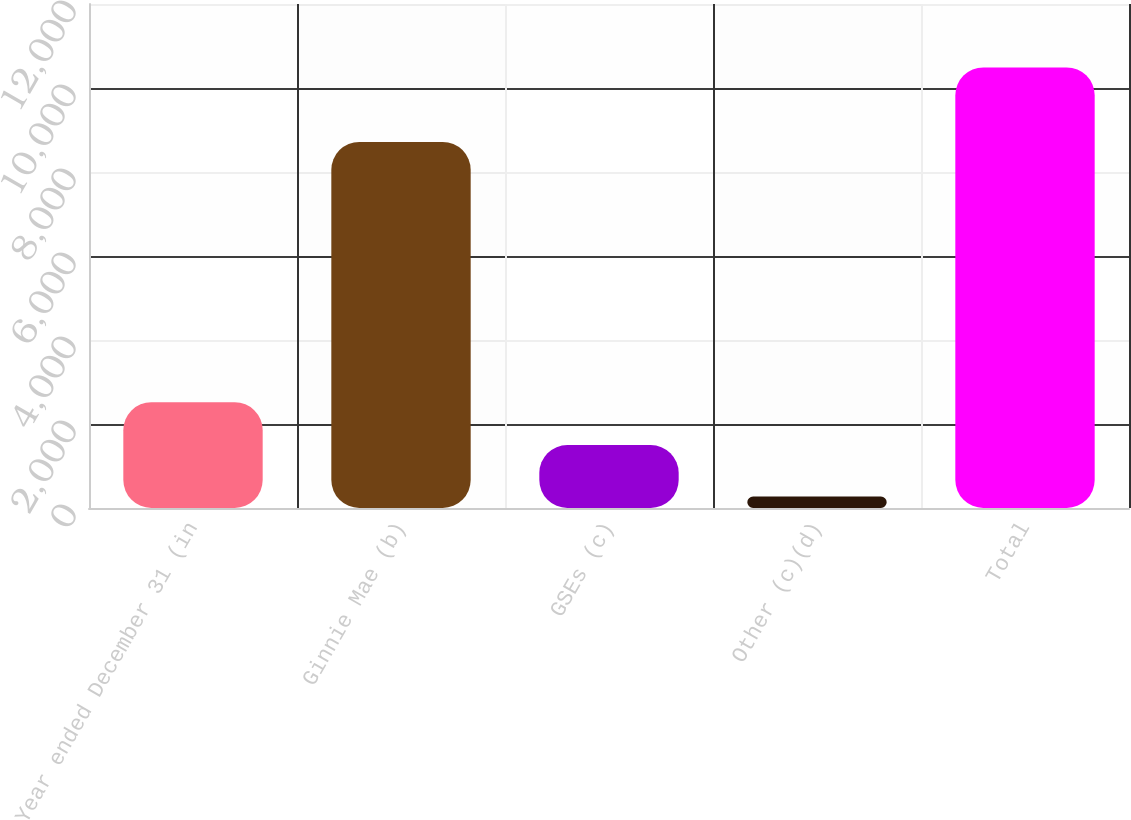<chart> <loc_0><loc_0><loc_500><loc_500><bar_chart><fcel>Year ended December 31 (in<fcel>Ginnie Mae (b)<fcel>GSEs (c)<fcel>Other (c)(d)<fcel>Total<nl><fcel>2519.5<fcel>8717<fcel>1498<fcel>275<fcel>10490<nl></chart> 